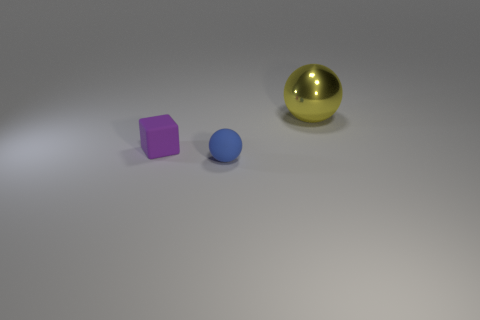Does the small thing behind the rubber ball have the same material as the small sphere?
Provide a short and direct response. Yes. Is there anything else that is the same size as the blue object?
Provide a short and direct response. Yes. Are there fewer large metal objects that are to the right of the large yellow ball than purple things to the right of the rubber block?
Offer a terse response. No. Are there any other things that have the same shape as the purple rubber object?
Provide a succinct answer. No. There is a sphere on the left side of the ball that is behind the tiny blue thing; what number of tiny cubes are behind it?
Your response must be concise. 1. What number of purple objects are in front of the tiny purple thing?
Your response must be concise. 0. What number of purple cubes are the same material as the tiny blue object?
Give a very brief answer. 1. The tiny object that is made of the same material as the small blue sphere is what color?
Make the answer very short. Purple. What is the material of the small object behind the sphere that is in front of the ball behind the tiny purple thing?
Ensure brevity in your answer.  Rubber. Do the ball that is to the left of the yellow ball and the metallic thing have the same size?
Keep it short and to the point. No. 